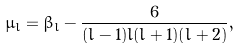Convert formula to latex. <formula><loc_0><loc_0><loc_500><loc_500>\mu _ { l } = \beta _ { l } - \frac { 6 } { ( l - 1 ) l ( l + 1 ) ( l + 2 ) } ,</formula> 